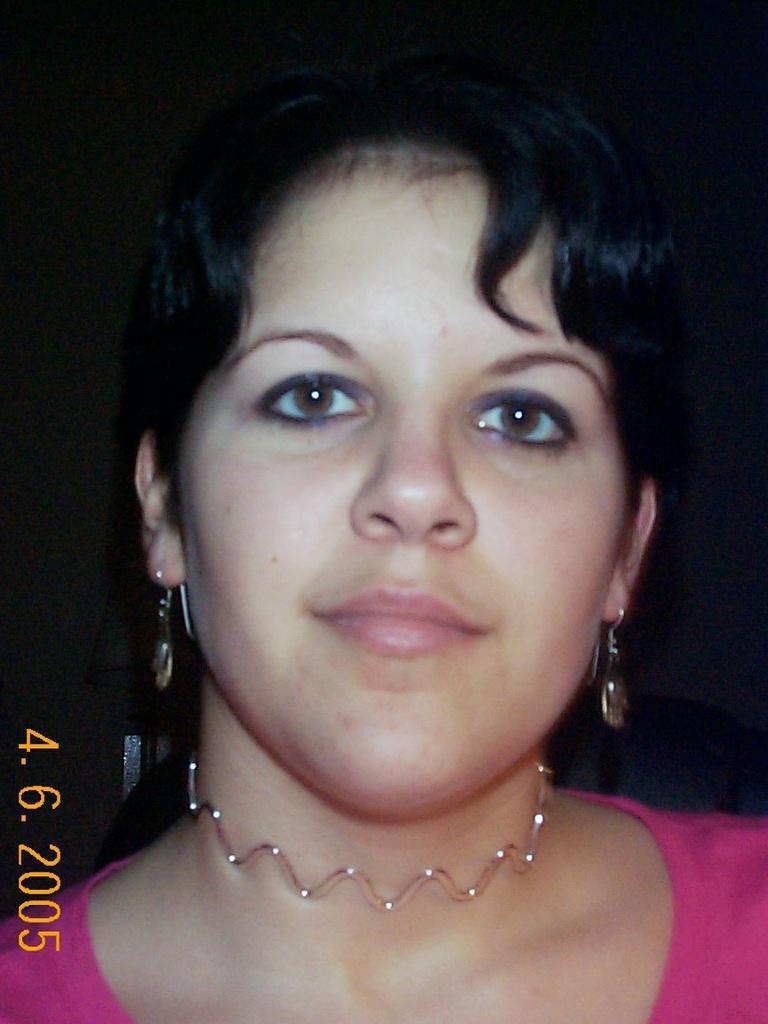Describe this image in one or two sentences. In this picture we can see a woman's face in the front, at the left bottom there is a date, month and year, we can see a dark background. 